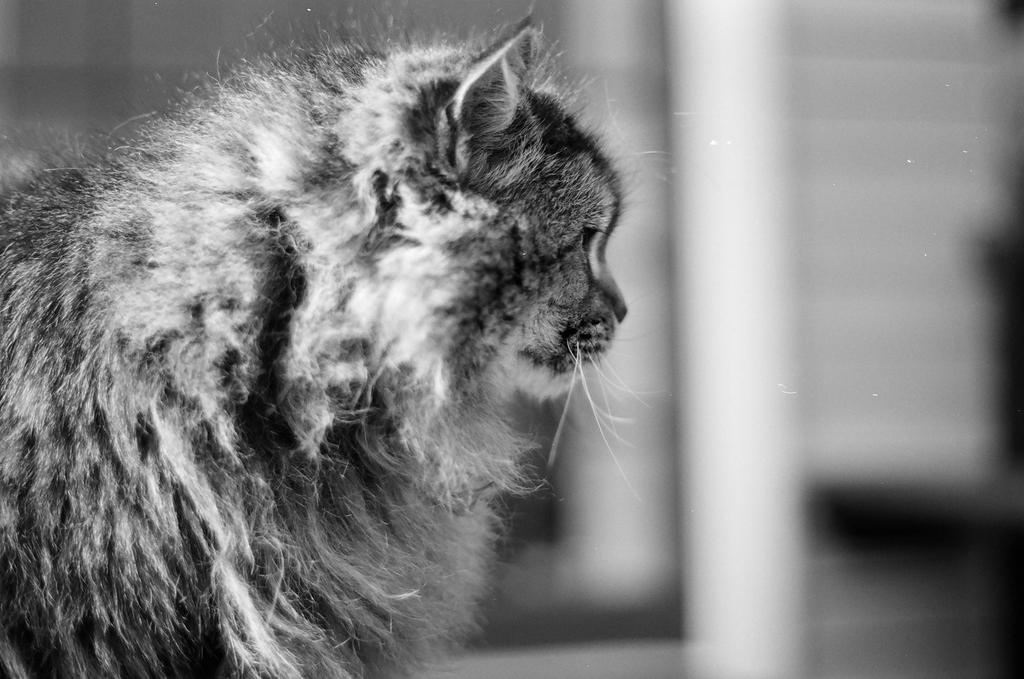Can you describe this image briefly? This is a black and white image. In this image we can see a cat. In the background it is blur. 